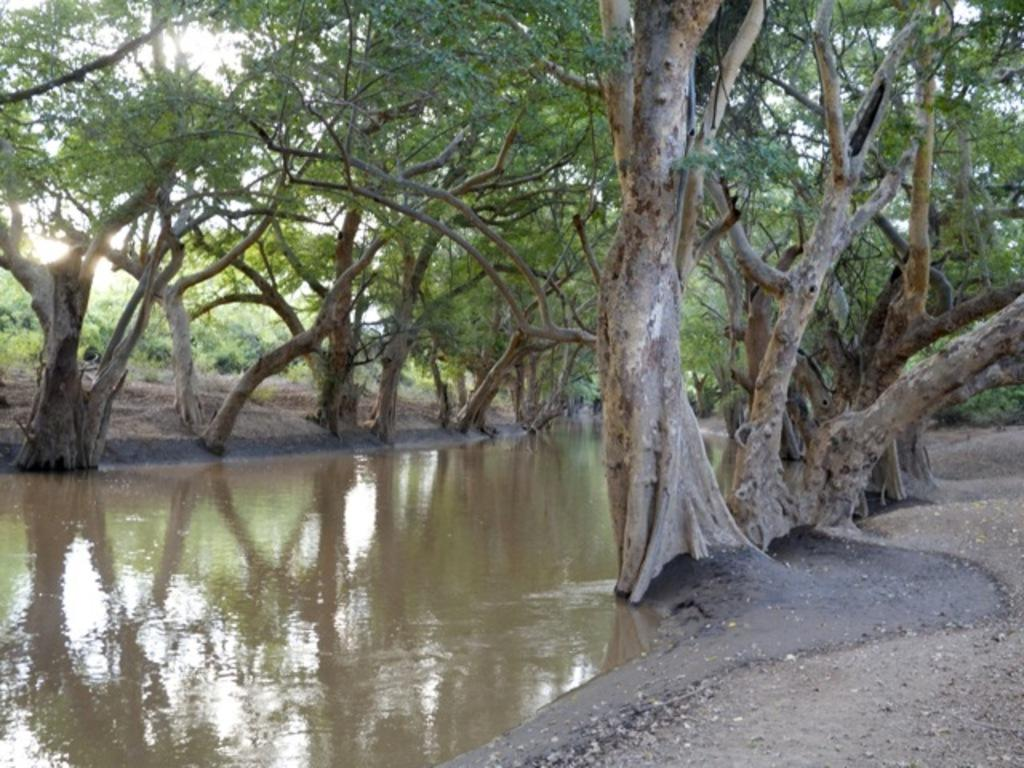What is flowing on the left side of the image? There is water flowing on the left side of the image. What can be seen in the middle of the image? There are trees in the middle of the image. What type of terrain is on the right side of the image? There is sand on the right side of the image. How many cats are sitting on the bread in the image? There are no cats or bread present in the image. What type of hope can be seen in the image? There is no representation of hope in the image; it features water, trees, and sand. 